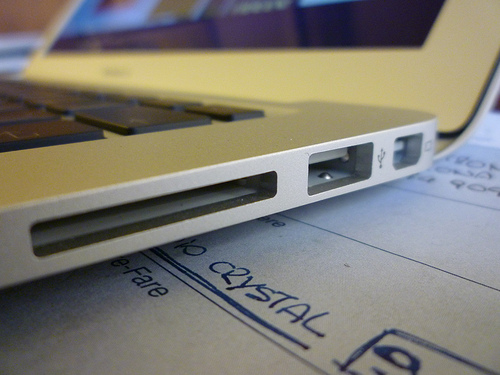<image>
Is there a keyboard under the screen? Yes. The keyboard is positioned underneath the screen, with the screen above it in the vertical space. 